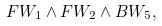<formula> <loc_0><loc_0><loc_500><loc_500>F W _ { 1 } \wedge F W _ { 2 } \wedge B W _ { 5 } ,</formula> 